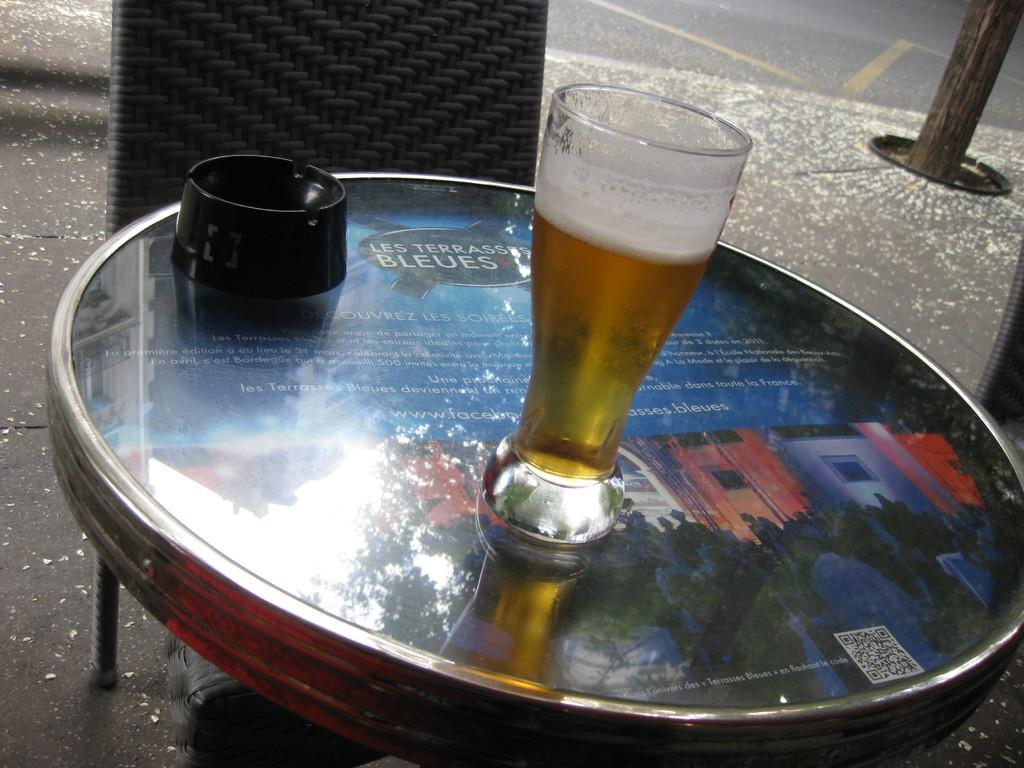What piece of furniture is present in the image? There is a table in the image. What is placed on the table? There is a drink containing a glass on the table. What is in front of the table? There is a chair in front of the table. What can be seen on the right side of the table? There is a stand visible on the right side of the table. How much money is on the table in the image? There is no mention of money in the image; it only contains a table, a drink with a glass, a chair, and a stand. Is there a zebra sitting on the chair in the image? No, there is no zebra present in the image. 